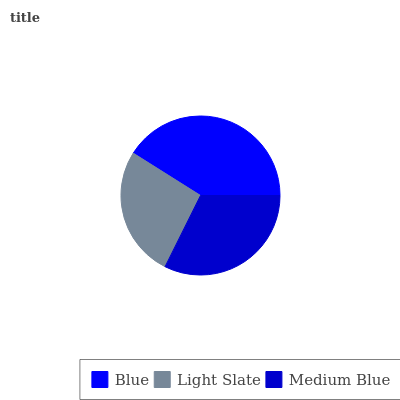Is Light Slate the minimum?
Answer yes or no. Yes. Is Blue the maximum?
Answer yes or no. Yes. Is Medium Blue the minimum?
Answer yes or no. No. Is Medium Blue the maximum?
Answer yes or no. No. Is Medium Blue greater than Light Slate?
Answer yes or no. Yes. Is Light Slate less than Medium Blue?
Answer yes or no. Yes. Is Light Slate greater than Medium Blue?
Answer yes or no. No. Is Medium Blue less than Light Slate?
Answer yes or no. No. Is Medium Blue the high median?
Answer yes or no. Yes. Is Medium Blue the low median?
Answer yes or no. Yes. Is Light Slate the high median?
Answer yes or no. No. Is Blue the low median?
Answer yes or no. No. 